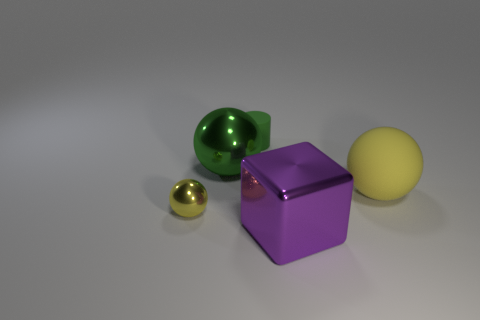Add 2 cubes. How many objects exist? 7 Subtract all spheres. How many objects are left? 2 Add 2 tiny yellow shiny balls. How many tiny yellow shiny balls are left? 3 Add 1 cyan cubes. How many cyan cubes exist? 1 Subtract 0 red balls. How many objects are left? 5 Subtract all blue objects. Subtract all large purple shiny objects. How many objects are left? 4 